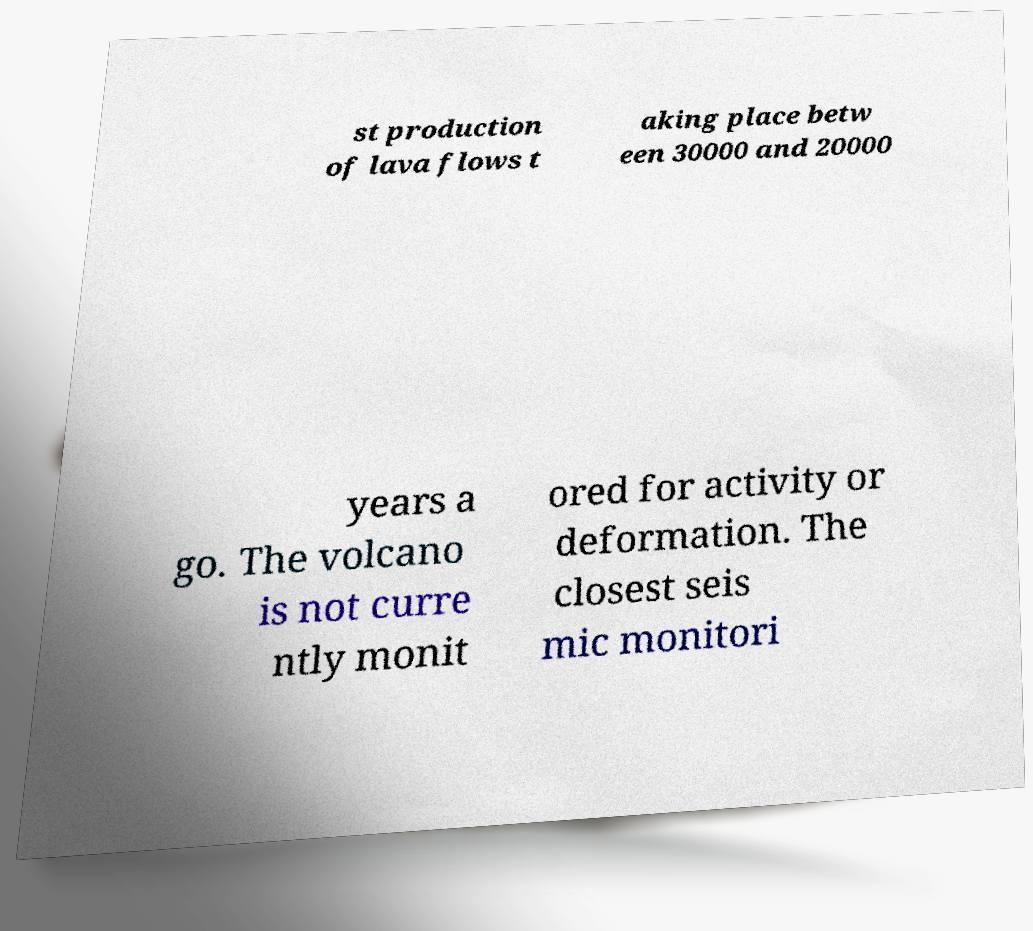I need the written content from this picture converted into text. Can you do that? st production of lava flows t aking place betw een 30000 and 20000 years a go. The volcano is not curre ntly monit ored for activity or deformation. The closest seis mic monitori 